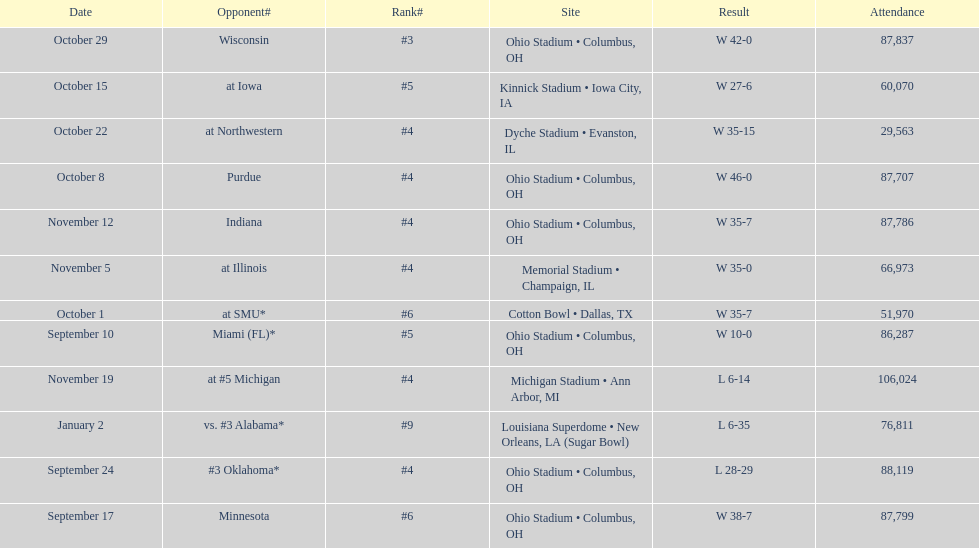What was the total number of victories for this team in the current season? 9. 